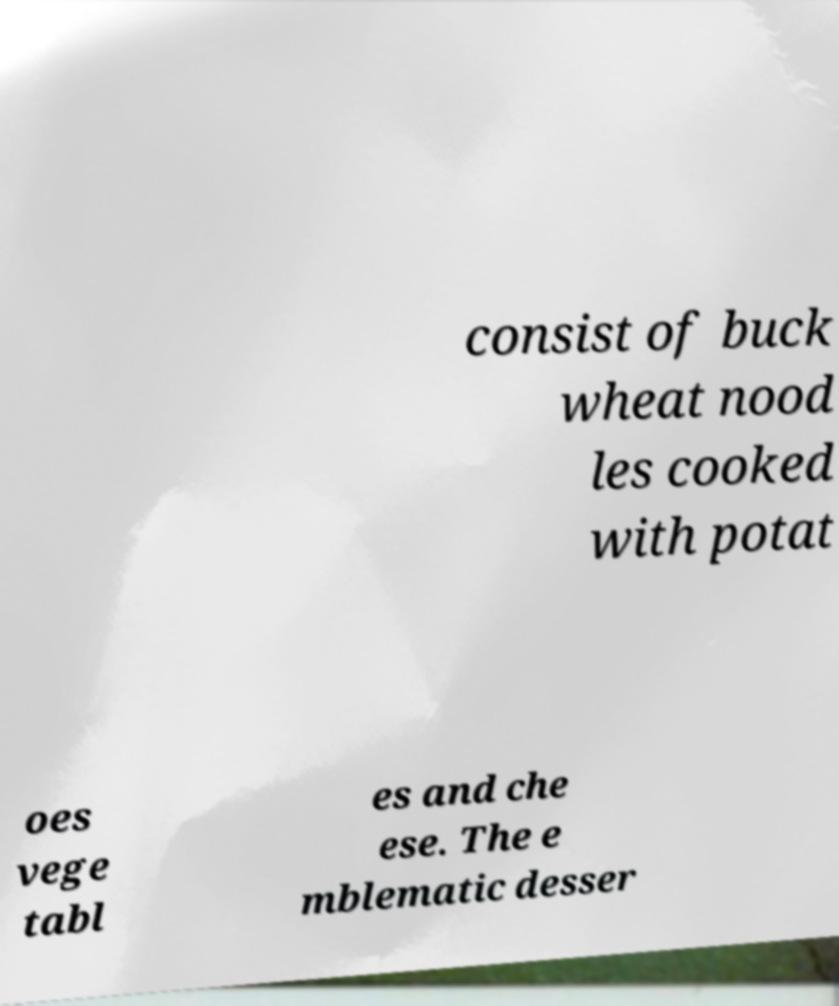Please identify and transcribe the text found in this image. consist of buck wheat nood les cooked with potat oes vege tabl es and che ese. The e mblematic desser 